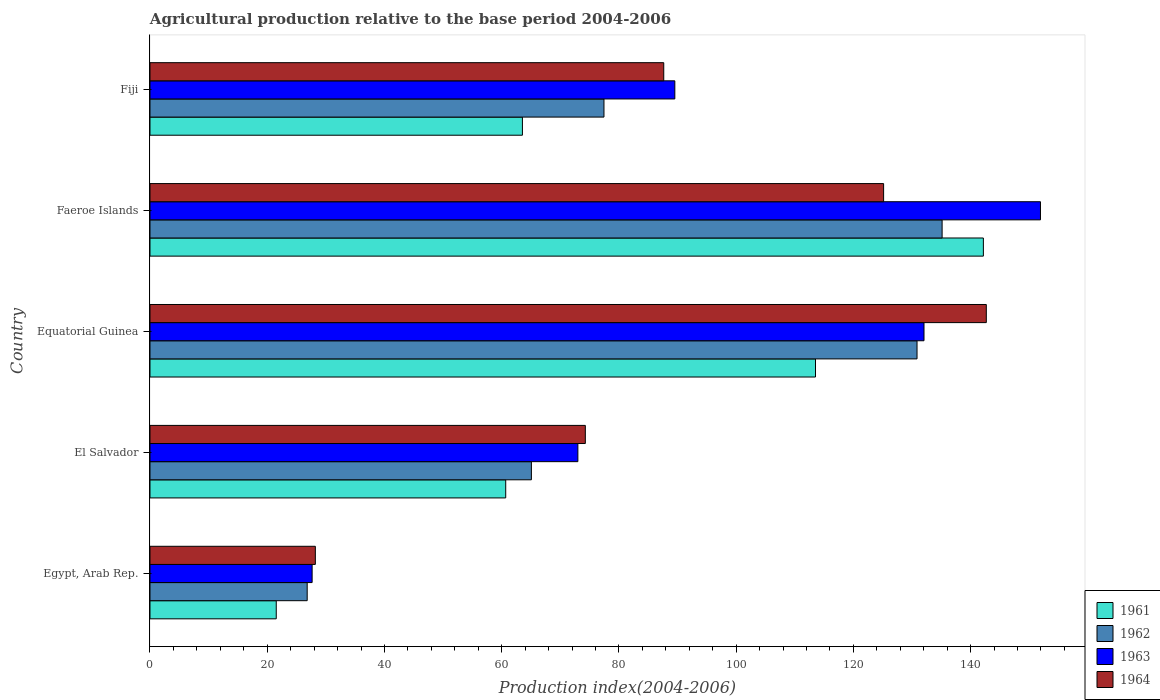Are the number of bars on each tick of the Y-axis equal?
Your answer should be compact. Yes. How many bars are there on the 1st tick from the top?
Your answer should be very brief. 4. What is the label of the 4th group of bars from the top?
Provide a succinct answer. El Salvador. What is the agricultural production index in 1962 in El Salvador?
Your answer should be compact. 65.07. Across all countries, what is the maximum agricultural production index in 1964?
Offer a very short reply. 142.68. Across all countries, what is the minimum agricultural production index in 1964?
Your response must be concise. 28.21. In which country was the agricultural production index in 1964 maximum?
Give a very brief answer. Equatorial Guinea. In which country was the agricultural production index in 1964 minimum?
Provide a short and direct response. Egypt, Arab Rep. What is the total agricultural production index in 1963 in the graph?
Give a very brief answer. 474.17. What is the difference between the agricultural production index in 1961 in Egypt, Arab Rep. and that in Fiji?
Offer a very short reply. -42. What is the difference between the agricultural production index in 1961 in Faeroe Islands and the agricultural production index in 1962 in El Salvador?
Make the answer very short. 77.11. What is the average agricultural production index in 1964 per country?
Your answer should be compact. 91.59. What is the difference between the agricultural production index in 1963 and agricultural production index in 1964 in El Salvador?
Provide a succinct answer. -1.27. In how many countries, is the agricultural production index in 1961 greater than 52 ?
Your answer should be very brief. 4. What is the ratio of the agricultural production index in 1962 in Equatorial Guinea to that in Fiji?
Ensure brevity in your answer.  1.69. Is the agricultural production index in 1963 in Egypt, Arab Rep. less than that in Equatorial Guinea?
Offer a very short reply. Yes. What is the difference between the highest and the second highest agricultural production index in 1963?
Your answer should be very brief. 19.87. What is the difference between the highest and the lowest agricultural production index in 1962?
Provide a short and direct response. 108.32. In how many countries, is the agricultural production index in 1963 greater than the average agricultural production index in 1963 taken over all countries?
Provide a short and direct response. 2. Is the sum of the agricultural production index in 1963 in El Salvador and Faeroe Islands greater than the maximum agricultural production index in 1964 across all countries?
Offer a terse response. Yes. Is it the case that in every country, the sum of the agricultural production index in 1961 and agricultural production index in 1962 is greater than the sum of agricultural production index in 1963 and agricultural production index in 1964?
Ensure brevity in your answer.  No. Is it the case that in every country, the sum of the agricultural production index in 1961 and agricultural production index in 1962 is greater than the agricultural production index in 1964?
Provide a short and direct response. Yes. How many bars are there?
Ensure brevity in your answer.  20. Are all the bars in the graph horizontal?
Make the answer very short. Yes. How many countries are there in the graph?
Ensure brevity in your answer.  5. What is the difference between two consecutive major ticks on the X-axis?
Give a very brief answer. 20. Are the values on the major ticks of X-axis written in scientific E-notation?
Ensure brevity in your answer.  No. Does the graph contain any zero values?
Your response must be concise. No. How many legend labels are there?
Ensure brevity in your answer.  4. How are the legend labels stacked?
Give a very brief answer. Vertical. What is the title of the graph?
Make the answer very short. Agricultural production relative to the base period 2004-2006. What is the label or title of the X-axis?
Provide a succinct answer. Production index(2004-2006). What is the Production index(2004-2006) in 1961 in Egypt, Arab Rep.?
Provide a succinct answer. 21.54. What is the Production index(2004-2006) in 1962 in Egypt, Arab Rep.?
Ensure brevity in your answer.  26.82. What is the Production index(2004-2006) in 1963 in Egypt, Arab Rep.?
Ensure brevity in your answer.  27.66. What is the Production index(2004-2006) of 1964 in Egypt, Arab Rep.?
Make the answer very short. 28.21. What is the Production index(2004-2006) of 1961 in El Salvador?
Your answer should be compact. 60.69. What is the Production index(2004-2006) of 1962 in El Salvador?
Offer a very short reply. 65.07. What is the Production index(2004-2006) in 1964 in El Salvador?
Your answer should be very brief. 74.27. What is the Production index(2004-2006) in 1961 in Equatorial Guinea?
Make the answer very short. 113.54. What is the Production index(2004-2006) in 1962 in Equatorial Guinea?
Provide a short and direct response. 130.86. What is the Production index(2004-2006) of 1963 in Equatorial Guinea?
Offer a terse response. 132.05. What is the Production index(2004-2006) of 1964 in Equatorial Guinea?
Give a very brief answer. 142.68. What is the Production index(2004-2006) of 1961 in Faeroe Islands?
Keep it short and to the point. 142.18. What is the Production index(2004-2006) in 1962 in Faeroe Islands?
Give a very brief answer. 135.14. What is the Production index(2004-2006) of 1963 in Faeroe Islands?
Keep it short and to the point. 151.92. What is the Production index(2004-2006) in 1964 in Faeroe Islands?
Provide a short and direct response. 125.16. What is the Production index(2004-2006) in 1961 in Fiji?
Your answer should be compact. 63.54. What is the Production index(2004-2006) in 1962 in Fiji?
Your answer should be very brief. 77.45. What is the Production index(2004-2006) in 1963 in Fiji?
Your answer should be compact. 89.54. What is the Production index(2004-2006) in 1964 in Fiji?
Make the answer very short. 87.65. Across all countries, what is the maximum Production index(2004-2006) in 1961?
Give a very brief answer. 142.18. Across all countries, what is the maximum Production index(2004-2006) in 1962?
Provide a succinct answer. 135.14. Across all countries, what is the maximum Production index(2004-2006) in 1963?
Offer a very short reply. 151.92. Across all countries, what is the maximum Production index(2004-2006) in 1964?
Offer a very short reply. 142.68. Across all countries, what is the minimum Production index(2004-2006) in 1961?
Provide a short and direct response. 21.54. Across all countries, what is the minimum Production index(2004-2006) of 1962?
Offer a terse response. 26.82. Across all countries, what is the minimum Production index(2004-2006) in 1963?
Make the answer very short. 27.66. Across all countries, what is the minimum Production index(2004-2006) in 1964?
Offer a very short reply. 28.21. What is the total Production index(2004-2006) in 1961 in the graph?
Provide a short and direct response. 401.49. What is the total Production index(2004-2006) of 1962 in the graph?
Your answer should be compact. 435.34. What is the total Production index(2004-2006) of 1963 in the graph?
Provide a short and direct response. 474.17. What is the total Production index(2004-2006) in 1964 in the graph?
Provide a succinct answer. 457.97. What is the difference between the Production index(2004-2006) in 1961 in Egypt, Arab Rep. and that in El Salvador?
Your answer should be very brief. -39.15. What is the difference between the Production index(2004-2006) in 1962 in Egypt, Arab Rep. and that in El Salvador?
Provide a succinct answer. -38.25. What is the difference between the Production index(2004-2006) of 1963 in Egypt, Arab Rep. and that in El Salvador?
Offer a very short reply. -45.34. What is the difference between the Production index(2004-2006) in 1964 in Egypt, Arab Rep. and that in El Salvador?
Your answer should be very brief. -46.06. What is the difference between the Production index(2004-2006) of 1961 in Egypt, Arab Rep. and that in Equatorial Guinea?
Make the answer very short. -92. What is the difference between the Production index(2004-2006) of 1962 in Egypt, Arab Rep. and that in Equatorial Guinea?
Ensure brevity in your answer.  -104.04. What is the difference between the Production index(2004-2006) in 1963 in Egypt, Arab Rep. and that in Equatorial Guinea?
Give a very brief answer. -104.39. What is the difference between the Production index(2004-2006) in 1964 in Egypt, Arab Rep. and that in Equatorial Guinea?
Your answer should be very brief. -114.47. What is the difference between the Production index(2004-2006) in 1961 in Egypt, Arab Rep. and that in Faeroe Islands?
Provide a short and direct response. -120.64. What is the difference between the Production index(2004-2006) of 1962 in Egypt, Arab Rep. and that in Faeroe Islands?
Your response must be concise. -108.32. What is the difference between the Production index(2004-2006) of 1963 in Egypt, Arab Rep. and that in Faeroe Islands?
Your response must be concise. -124.26. What is the difference between the Production index(2004-2006) in 1964 in Egypt, Arab Rep. and that in Faeroe Islands?
Keep it short and to the point. -96.95. What is the difference between the Production index(2004-2006) of 1961 in Egypt, Arab Rep. and that in Fiji?
Your answer should be compact. -42. What is the difference between the Production index(2004-2006) in 1962 in Egypt, Arab Rep. and that in Fiji?
Your answer should be compact. -50.63. What is the difference between the Production index(2004-2006) of 1963 in Egypt, Arab Rep. and that in Fiji?
Make the answer very short. -61.88. What is the difference between the Production index(2004-2006) of 1964 in Egypt, Arab Rep. and that in Fiji?
Keep it short and to the point. -59.44. What is the difference between the Production index(2004-2006) of 1961 in El Salvador and that in Equatorial Guinea?
Offer a terse response. -52.85. What is the difference between the Production index(2004-2006) in 1962 in El Salvador and that in Equatorial Guinea?
Keep it short and to the point. -65.79. What is the difference between the Production index(2004-2006) of 1963 in El Salvador and that in Equatorial Guinea?
Your answer should be very brief. -59.05. What is the difference between the Production index(2004-2006) of 1964 in El Salvador and that in Equatorial Guinea?
Keep it short and to the point. -68.41. What is the difference between the Production index(2004-2006) in 1961 in El Salvador and that in Faeroe Islands?
Your response must be concise. -81.49. What is the difference between the Production index(2004-2006) of 1962 in El Salvador and that in Faeroe Islands?
Give a very brief answer. -70.07. What is the difference between the Production index(2004-2006) in 1963 in El Salvador and that in Faeroe Islands?
Ensure brevity in your answer.  -78.92. What is the difference between the Production index(2004-2006) of 1964 in El Salvador and that in Faeroe Islands?
Give a very brief answer. -50.89. What is the difference between the Production index(2004-2006) of 1961 in El Salvador and that in Fiji?
Provide a succinct answer. -2.85. What is the difference between the Production index(2004-2006) in 1962 in El Salvador and that in Fiji?
Ensure brevity in your answer.  -12.38. What is the difference between the Production index(2004-2006) of 1963 in El Salvador and that in Fiji?
Ensure brevity in your answer.  -16.54. What is the difference between the Production index(2004-2006) of 1964 in El Salvador and that in Fiji?
Your answer should be compact. -13.38. What is the difference between the Production index(2004-2006) in 1961 in Equatorial Guinea and that in Faeroe Islands?
Provide a short and direct response. -28.64. What is the difference between the Production index(2004-2006) of 1962 in Equatorial Guinea and that in Faeroe Islands?
Your response must be concise. -4.28. What is the difference between the Production index(2004-2006) in 1963 in Equatorial Guinea and that in Faeroe Islands?
Give a very brief answer. -19.87. What is the difference between the Production index(2004-2006) of 1964 in Equatorial Guinea and that in Faeroe Islands?
Your response must be concise. 17.52. What is the difference between the Production index(2004-2006) of 1962 in Equatorial Guinea and that in Fiji?
Give a very brief answer. 53.41. What is the difference between the Production index(2004-2006) of 1963 in Equatorial Guinea and that in Fiji?
Your response must be concise. 42.51. What is the difference between the Production index(2004-2006) of 1964 in Equatorial Guinea and that in Fiji?
Provide a short and direct response. 55.03. What is the difference between the Production index(2004-2006) of 1961 in Faeroe Islands and that in Fiji?
Provide a succinct answer. 78.64. What is the difference between the Production index(2004-2006) of 1962 in Faeroe Islands and that in Fiji?
Offer a very short reply. 57.69. What is the difference between the Production index(2004-2006) in 1963 in Faeroe Islands and that in Fiji?
Give a very brief answer. 62.38. What is the difference between the Production index(2004-2006) in 1964 in Faeroe Islands and that in Fiji?
Give a very brief answer. 37.51. What is the difference between the Production index(2004-2006) in 1961 in Egypt, Arab Rep. and the Production index(2004-2006) in 1962 in El Salvador?
Make the answer very short. -43.53. What is the difference between the Production index(2004-2006) of 1961 in Egypt, Arab Rep. and the Production index(2004-2006) of 1963 in El Salvador?
Provide a short and direct response. -51.46. What is the difference between the Production index(2004-2006) in 1961 in Egypt, Arab Rep. and the Production index(2004-2006) in 1964 in El Salvador?
Your response must be concise. -52.73. What is the difference between the Production index(2004-2006) of 1962 in Egypt, Arab Rep. and the Production index(2004-2006) of 1963 in El Salvador?
Provide a succinct answer. -46.18. What is the difference between the Production index(2004-2006) of 1962 in Egypt, Arab Rep. and the Production index(2004-2006) of 1964 in El Salvador?
Offer a very short reply. -47.45. What is the difference between the Production index(2004-2006) in 1963 in Egypt, Arab Rep. and the Production index(2004-2006) in 1964 in El Salvador?
Provide a short and direct response. -46.61. What is the difference between the Production index(2004-2006) of 1961 in Egypt, Arab Rep. and the Production index(2004-2006) of 1962 in Equatorial Guinea?
Provide a succinct answer. -109.32. What is the difference between the Production index(2004-2006) of 1961 in Egypt, Arab Rep. and the Production index(2004-2006) of 1963 in Equatorial Guinea?
Your answer should be very brief. -110.51. What is the difference between the Production index(2004-2006) in 1961 in Egypt, Arab Rep. and the Production index(2004-2006) in 1964 in Equatorial Guinea?
Your answer should be compact. -121.14. What is the difference between the Production index(2004-2006) of 1962 in Egypt, Arab Rep. and the Production index(2004-2006) of 1963 in Equatorial Guinea?
Your answer should be compact. -105.23. What is the difference between the Production index(2004-2006) in 1962 in Egypt, Arab Rep. and the Production index(2004-2006) in 1964 in Equatorial Guinea?
Give a very brief answer. -115.86. What is the difference between the Production index(2004-2006) in 1963 in Egypt, Arab Rep. and the Production index(2004-2006) in 1964 in Equatorial Guinea?
Provide a short and direct response. -115.02. What is the difference between the Production index(2004-2006) of 1961 in Egypt, Arab Rep. and the Production index(2004-2006) of 1962 in Faeroe Islands?
Ensure brevity in your answer.  -113.6. What is the difference between the Production index(2004-2006) of 1961 in Egypt, Arab Rep. and the Production index(2004-2006) of 1963 in Faeroe Islands?
Make the answer very short. -130.38. What is the difference between the Production index(2004-2006) in 1961 in Egypt, Arab Rep. and the Production index(2004-2006) in 1964 in Faeroe Islands?
Provide a short and direct response. -103.62. What is the difference between the Production index(2004-2006) in 1962 in Egypt, Arab Rep. and the Production index(2004-2006) in 1963 in Faeroe Islands?
Your answer should be compact. -125.1. What is the difference between the Production index(2004-2006) in 1962 in Egypt, Arab Rep. and the Production index(2004-2006) in 1964 in Faeroe Islands?
Give a very brief answer. -98.34. What is the difference between the Production index(2004-2006) of 1963 in Egypt, Arab Rep. and the Production index(2004-2006) of 1964 in Faeroe Islands?
Your answer should be compact. -97.5. What is the difference between the Production index(2004-2006) of 1961 in Egypt, Arab Rep. and the Production index(2004-2006) of 1962 in Fiji?
Make the answer very short. -55.91. What is the difference between the Production index(2004-2006) in 1961 in Egypt, Arab Rep. and the Production index(2004-2006) in 1963 in Fiji?
Offer a terse response. -68. What is the difference between the Production index(2004-2006) of 1961 in Egypt, Arab Rep. and the Production index(2004-2006) of 1964 in Fiji?
Your response must be concise. -66.11. What is the difference between the Production index(2004-2006) of 1962 in Egypt, Arab Rep. and the Production index(2004-2006) of 1963 in Fiji?
Provide a short and direct response. -62.72. What is the difference between the Production index(2004-2006) of 1962 in Egypt, Arab Rep. and the Production index(2004-2006) of 1964 in Fiji?
Provide a succinct answer. -60.83. What is the difference between the Production index(2004-2006) in 1963 in Egypt, Arab Rep. and the Production index(2004-2006) in 1964 in Fiji?
Your answer should be very brief. -59.99. What is the difference between the Production index(2004-2006) of 1961 in El Salvador and the Production index(2004-2006) of 1962 in Equatorial Guinea?
Offer a very short reply. -70.17. What is the difference between the Production index(2004-2006) in 1961 in El Salvador and the Production index(2004-2006) in 1963 in Equatorial Guinea?
Make the answer very short. -71.36. What is the difference between the Production index(2004-2006) of 1961 in El Salvador and the Production index(2004-2006) of 1964 in Equatorial Guinea?
Your answer should be very brief. -81.99. What is the difference between the Production index(2004-2006) in 1962 in El Salvador and the Production index(2004-2006) in 1963 in Equatorial Guinea?
Provide a short and direct response. -66.98. What is the difference between the Production index(2004-2006) in 1962 in El Salvador and the Production index(2004-2006) in 1964 in Equatorial Guinea?
Offer a terse response. -77.61. What is the difference between the Production index(2004-2006) in 1963 in El Salvador and the Production index(2004-2006) in 1964 in Equatorial Guinea?
Offer a very short reply. -69.68. What is the difference between the Production index(2004-2006) in 1961 in El Salvador and the Production index(2004-2006) in 1962 in Faeroe Islands?
Ensure brevity in your answer.  -74.45. What is the difference between the Production index(2004-2006) of 1961 in El Salvador and the Production index(2004-2006) of 1963 in Faeroe Islands?
Offer a terse response. -91.23. What is the difference between the Production index(2004-2006) of 1961 in El Salvador and the Production index(2004-2006) of 1964 in Faeroe Islands?
Provide a short and direct response. -64.47. What is the difference between the Production index(2004-2006) of 1962 in El Salvador and the Production index(2004-2006) of 1963 in Faeroe Islands?
Give a very brief answer. -86.85. What is the difference between the Production index(2004-2006) in 1962 in El Salvador and the Production index(2004-2006) in 1964 in Faeroe Islands?
Make the answer very short. -60.09. What is the difference between the Production index(2004-2006) of 1963 in El Salvador and the Production index(2004-2006) of 1964 in Faeroe Islands?
Your answer should be very brief. -52.16. What is the difference between the Production index(2004-2006) of 1961 in El Salvador and the Production index(2004-2006) of 1962 in Fiji?
Your answer should be compact. -16.76. What is the difference between the Production index(2004-2006) of 1961 in El Salvador and the Production index(2004-2006) of 1963 in Fiji?
Your answer should be very brief. -28.85. What is the difference between the Production index(2004-2006) in 1961 in El Salvador and the Production index(2004-2006) in 1964 in Fiji?
Keep it short and to the point. -26.96. What is the difference between the Production index(2004-2006) of 1962 in El Salvador and the Production index(2004-2006) of 1963 in Fiji?
Offer a very short reply. -24.47. What is the difference between the Production index(2004-2006) in 1962 in El Salvador and the Production index(2004-2006) in 1964 in Fiji?
Your answer should be very brief. -22.58. What is the difference between the Production index(2004-2006) in 1963 in El Salvador and the Production index(2004-2006) in 1964 in Fiji?
Your answer should be very brief. -14.65. What is the difference between the Production index(2004-2006) of 1961 in Equatorial Guinea and the Production index(2004-2006) of 1962 in Faeroe Islands?
Offer a terse response. -21.6. What is the difference between the Production index(2004-2006) in 1961 in Equatorial Guinea and the Production index(2004-2006) in 1963 in Faeroe Islands?
Your answer should be compact. -38.38. What is the difference between the Production index(2004-2006) in 1961 in Equatorial Guinea and the Production index(2004-2006) in 1964 in Faeroe Islands?
Your answer should be very brief. -11.62. What is the difference between the Production index(2004-2006) in 1962 in Equatorial Guinea and the Production index(2004-2006) in 1963 in Faeroe Islands?
Your response must be concise. -21.06. What is the difference between the Production index(2004-2006) of 1963 in Equatorial Guinea and the Production index(2004-2006) of 1964 in Faeroe Islands?
Give a very brief answer. 6.89. What is the difference between the Production index(2004-2006) of 1961 in Equatorial Guinea and the Production index(2004-2006) of 1962 in Fiji?
Offer a very short reply. 36.09. What is the difference between the Production index(2004-2006) in 1961 in Equatorial Guinea and the Production index(2004-2006) in 1964 in Fiji?
Your answer should be compact. 25.89. What is the difference between the Production index(2004-2006) of 1962 in Equatorial Guinea and the Production index(2004-2006) of 1963 in Fiji?
Your answer should be compact. 41.32. What is the difference between the Production index(2004-2006) in 1962 in Equatorial Guinea and the Production index(2004-2006) in 1964 in Fiji?
Provide a succinct answer. 43.21. What is the difference between the Production index(2004-2006) of 1963 in Equatorial Guinea and the Production index(2004-2006) of 1964 in Fiji?
Make the answer very short. 44.4. What is the difference between the Production index(2004-2006) of 1961 in Faeroe Islands and the Production index(2004-2006) of 1962 in Fiji?
Provide a succinct answer. 64.73. What is the difference between the Production index(2004-2006) of 1961 in Faeroe Islands and the Production index(2004-2006) of 1963 in Fiji?
Your answer should be compact. 52.64. What is the difference between the Production index(2004-2006) of 1961 in Faeroe Islands and the Production index(2004-2006) of 1964 in Fiji?
Offer a terse response. 54.53. What is the difference between the Production index(2004-2006) of 1962 in Faeroe Islands and the Production index(2004-2006) of 1963 in Fiji?
Provide a succinct answer. 45.6. What is the difference between the Production index(2004-2006) of 1962 in Faeroe Islands and the Production index(2004-2006) of 1964 in Fiji?
Offer a terse response. 47.49. What is the difference between the Production index(2004-2006) in 1963 in Faeroe Islands and the Production index(2004-2006) in 1964 in Fiji?
Offer a very short reply. 64.27. What is the average Production index(2004-2006) in 1961 per country?
Your answer should be compact. 80.3. What is the average Production index(2004-2006) in 1962 per country?
Your answer should be very brief. 87.07. What is the average Production index(2004-2006) of 1963 per country?
Provide a succinct answer. 94.83. What is the average Production index(2004-2006) of 1964 per country?
Make the answer very short. 91.59. What is the difference between the Production index(2004-2006) of 1961 and Production index(2004-2006) of 1962 in Egypt, Arab Rep.?
Ensure brevity in your answer.  -5.28. What is the difference between the Production index(2004-2006) in 1961 and Production index(2004-2006) in 1963 in Egypt, Arab Rep.?
Keep it short and to the point. -6.12. What is the difference between the Production index(2004-2006) in 1961 and Production index(2004-2006) in 1964 in Egypt, Arab Rep.?
Your answer should be compact. -6.67. What is the difference between the Production index(2004-2006) of 1962 and Production index(2004-2006) of 1963 in Egypt, Arab Rep.?
Your response must be concise. -0.84. What is the difference between the Production index(2004-2006) in 1962 and Production index(2004-2006) in 1964 in Egypt, Arab Rep.?
Provide a short and direct response. -1.39. What is the difference between the Production index(2004-2006) in 1963 and Production index(2004-2006) in 1964 in Egypt, Arab Rep.?
Your answer should be compact. -0.55. What is the difference between the Production index(2004-2006) of 1961 and Production index(2004-2006) of 1962 in El Salvador?
Your response must be concise. -4.38. What is the difference between the Production index(2004-2006) in 1961 and Production index(2004-2006) in 1963 in El Salvador?
Offer a terse response. -12.31. What is the difference between the Production index(2004-2006) in 1961 and Production index(2004-2006) in 1964 in El Salvador?
Give a very brief answer. -13.58. What is the difference between the Production index(2004-2006) of 1962 and Production index(2004-2006) of 1963 in El Salvador?
Make the answer very short. -7.93. What is the difference between the Production index(2004-2006) in 1963 and Production index(2004-2006) in 1964 in El Salvador?
Ensure brevity in your answer.  -1.27. What is the difference between the Production index(2004-2006) of 1961 and Production index(2004-2006) of 1962 in Equatorial Guinea?
Offer a very short reply. -17.32. What is the difference between the Production index(2004-2006) in 1961 and Production index(2004-2006) in 1963 in Equatorial Guinea?
Your answer should be compact. -18.51. What is the difference between the Production index(2004-2006) of 1961 and Production index(2004-2006) of 1964 in Equatorial Guinea?
Your answer should be very brief. -29.14. What is the difference between the Production index(2004-2006) in 1962 and Production index(2004-2006) in 1963 in Equatorial Guinea?
Provide a short and direct response. -1.19. What is the difference between the Production index(2004-2006) in 1962 and Production index(2004-2006) in 1964 in Equatorial Guinea?
Your answer should be very brief. -11.82. What is the difference between the Production index(2004-2006) of 1963 and Production index(2004-2006) of 1964 in Equatorial Guinea?
Give a very brief answer. -10.63. What is the difference between the Production index(2004-2006) of 1961 and Production index(2004-2006) of 1962 in Faeroe Islands?
Give a very brief answer. 7.04. What is the difference between the Production index(2004-2006) in 1961 and Production index(2004-2006) in 1963 in Faeroe Islands?
Your response must be concise. -9.74. What is the difference between the Production index(2004-2006) of 1961 and Production index(2004-2006) of 1964 in Faeroe Islands?
Provide a succinct answer. 17.02. What is the difference between the Production index(2004-2006) of 1962 and Production index(2004-2006) of 1963 in Faeroe Islands?
Offer a very short reply. -16.78. What is the difference between the Production index(2004-2006) in 1962 and Production index(2004-2006) in 1964 in Faeroe Islands?
Keep it short and to the point. 9.98. What is the difference between the Production index(2004-2006) of 1963 and Production index(2004-2006) of 1964 in Faeroe Islands?
Offer a terse response. 26.76. What is the difference between the Production index(2004-2006) of 1961 and Production index(2004-2006) of 1962 in Fiji?
Provide a succinct answer. -13.91. What is the difference between the Production index(2004-2006) of 1961 and Production index(2004-2006) of 1963 in Fiji?
Your answer should be very brief. -26. What is the difference between the Production index(2004-2006) in 1961 and Production index(2004-2006) in 1964 in Fiji?
Offer a very short reply. -24.11. What is the difference between the Production index(2004-2006) of 1962 and Production index(2004-2006) of 1963 in Fiji?
Ensure brevity in your answer.  -12.09. What is the difference between the Production index(2004-2006) of 1962 and Production index(2004-2006) of 1964 in Fiji?
Your answer should be very brief. -10.2. What is the difference between the Production index(2004-2006) in 1963 and Production index(2004-2006) in 1964 in Fiji?
Provide a succinct answer. 1.89. What is the ratio of the Production index(2004-2006) in 1961 in Egypt, Arab Rep. to that in El Salvador?
Provide a succinct answer. 0.35. What is the ratio of the Production index(2004-2006) in 1962 in Egypt, Arab Rep. to that in El Salvador?
Your answer should be compact. 0.41. What is the ratio of the Production index(2004-2006) in 1963 in Egypt, Arab Rep. to that in El Salvador?
Keep it short and to the point. 0.38. What is the ratio of the Production index(2004-2006) in 1964 in Egypt, Arab Rep. to that in El Salvador?
Keep it short and to the point. 0.38. What is the ratio of the Production index(2004-2006) of 1961 in Egypt, Arab Rep. to that in Equatorial Guinea?
Provide a short and direct response. 0.19. What is the ratio of the Production index(2004-2006) in 1962 in Egypt, Arab Rep. to that in Equatorial Guinea?
Your answer should be compact. 0.2. What is the ratio of the Production index(2004-2006) of 1963 in Egypt, Arab Rep. to that in Equatorial Guinea?
Offer a very short reply. 0.21. What is the ratio of the Production index(2004-2006) in 1964 in Egypt, Arab Rep. to that in Equatorial Guinea?
Offer a very short reply. 0.2. What is the ratio of the Production index(2004-2006) in 1961 in Egypt, Arab Rep. to that in Faeroe Islands?
Your answer should be very brief. 0.15. What is the ratio of the Production index(2004-2006) of 1962 in Egypt, Arab Rep. to that in Faeroe Islands?
Offer a terse response. 0.2. What is the ratio of the Production index(2004-2006) of 1963 in Egypt, Arab Rep. to that in Faeroe Islands?
Your answer should be very brief. 0.18. What is the ratio of the Production index(2004-2006) in 1964 in Egypt, Arab Rep. to that in Faeroe Islands?
Make the answer very short. 0.23. What is the ratio of the Production index(2004-2006) in 1961 in Egypt, Arab Rep. to that in Fiji?
Ensure brevity in your answer.  0.34. What is the ratio of the Production index(2004-2006) of 1962 in Egypt, Arab Rep. to that in Fiji?
Provide a succinct answer. 0.35. What is the ratio of the Production index(2004-2006) in 1963 in Egypt, Arab Rep. to that in Fiji?
Your answer should be very brief. 0.31. What is the ratio of the Production index(2004-2006) of 1964 in Egypt, Arab Rep. to that in Fiji?
Provide a short and direct response. 0.32. What is the ratio of the Production index(2004-2006) of 1961 in El Salvador to that in Equatorial Guinea?
Provide a succinct answer. 0.53. What is the ratio of the Production index(2004-2006) in 1962 in El Salvador to that in Equatorial Guinea?
Provide a succinct answer. 0.5. What is the ratio of the Production index(2004-2006) of 1963 in El Salvador to that in Equatorial Guinea?
Ensure brevity in your answer.  0.55. What is the ratio of the Production index(2004-2006) in 1964 in El Salvador to that in Equatorial Guinea?
Your answer should be compact. 0.52. What is the ratio of the Production index(2004-2006) in 1961 in El Salvador to that in Faeroe Islands?
Ensure brevity in your answer.  0.43. What is the ratio of the Production index(2004-2006) in 1962 in El Salvador to that in Faeroe Islands?
Your response must be concise. 0.48. What is the ratio of the Production index(2004-2006) in 1963 in El Salvador to that in Faeroe Islands?
Ensure brevity in your answer.  0.48. What is the ratio of the Production index(2004-2006) of 1964 in El Salvador to that in Faeroe Islands?
Offer a very short reply. 0.59. What is the ratio of the Production index(2004-2006) in 1961 in El Salvador to that in Fiji?
Make the answer very short. 0.96. What is the ratio of the Production index(2004-2006) in 1962 in El Salvador to that in Fiji?
Ensure brevity in your answer.  0.84. What is the ratio of the Production index(2004-2006) in 1963 in El Salvador to that in Fiji?
Ensure brevity in your answer.  0.82. What is the ratio of the Production index(2004-2006) of 1964 in El Salvador to that in Fiji?
Your response must be concise. 0.85. What is the ratio of the Production index(2004-2006) of 1961 in Equatorial Guinea to that in Faeroe Islands?
Provide a succinct answer. 0.8. What is the ratio of the Production index(2004-2006) in 1962 in Equatorial Guinea to that in Faeroe Islands?
Give a very brief answer. 0.97. What is the ratio of the Production index(2004-2006) in 1963 in Equatorial Guinea to that in Faeroe Islands?
Make the answer very short. 0.87. What is the ratio of the Production index(2004-2006) in 1964 in Equatorial Guinea to that in Faeroe Islands?
Your answer should be compact. 1.14. What is the ratio of the Production index(2004-2006) in 1961 in Equatorial Guinea to that in Fiji?
Offer a terse response. 1.79. What is the ratio of the Production index(2004-2006) of 1962 in Equatorial Guinea to that in Fiji?
Make the answer very short. 1.69. What is the ratio of the Production index(2004-2006) of 1963 in Equatorial Guinea to that in Fiji?
Give a very brief answer. 1.47. What is the ratio of the Production index(2004-2006) in 1964 in Equatorial Guinea to that in Fiji?
Your answer should be compact. 1.63. What is the ratio of the Production index(2004-2006) of 1961 in Faeroe Islands to that in Fiji?
Your answer should be very brief. 2.24. What is the ratio of the Production index(2004-2006) in 1962 in Faeroe Islands to that in Fiji?
Provide a succinct answer. 1.74. What is the ratio of the Production index(2004-2006) in 1963 in Faeroe Islands to that in Fiji?
Your answer should be very brief. 1.7. What is the ratio of the Production index(2004-2006) of 1964 in Faeroe Islands to that in Fiji?
Offer a very short reply. 1.43. What is the difference between the highest and the second highest Production index(2004-2006) of 1961?
Ensure brevity in your answer.  28.64. What is the difference between the highest and the second highest Production index(2004-2006) in 1962?
Offer a terse response. 4.28. What is the difference between the highest and the second highest Production index(2004-2006) of 1963?
Provide a short and direct response. 19.87. What is the difference between the highest and the second highest Production index(2004-2006) in 1964?
Keep it short and to the point. 17.52. What is the difference between the highest and the lowest Production index(2004-2006) of 1961?
Provide a succinct answer. 120.64. What is the difference between the highest and the lowest Production index(2004-2006) in 1962?
Your answer should be very brief. 108.32. What is the difference between the highest and the lowest Production index(2004-2006) in 1963?
Offer a terse response. 124.26. What is the difference between the highest and the lowest Production index(2004-2006) of 1964?
Your response must be concise. 114.47. 